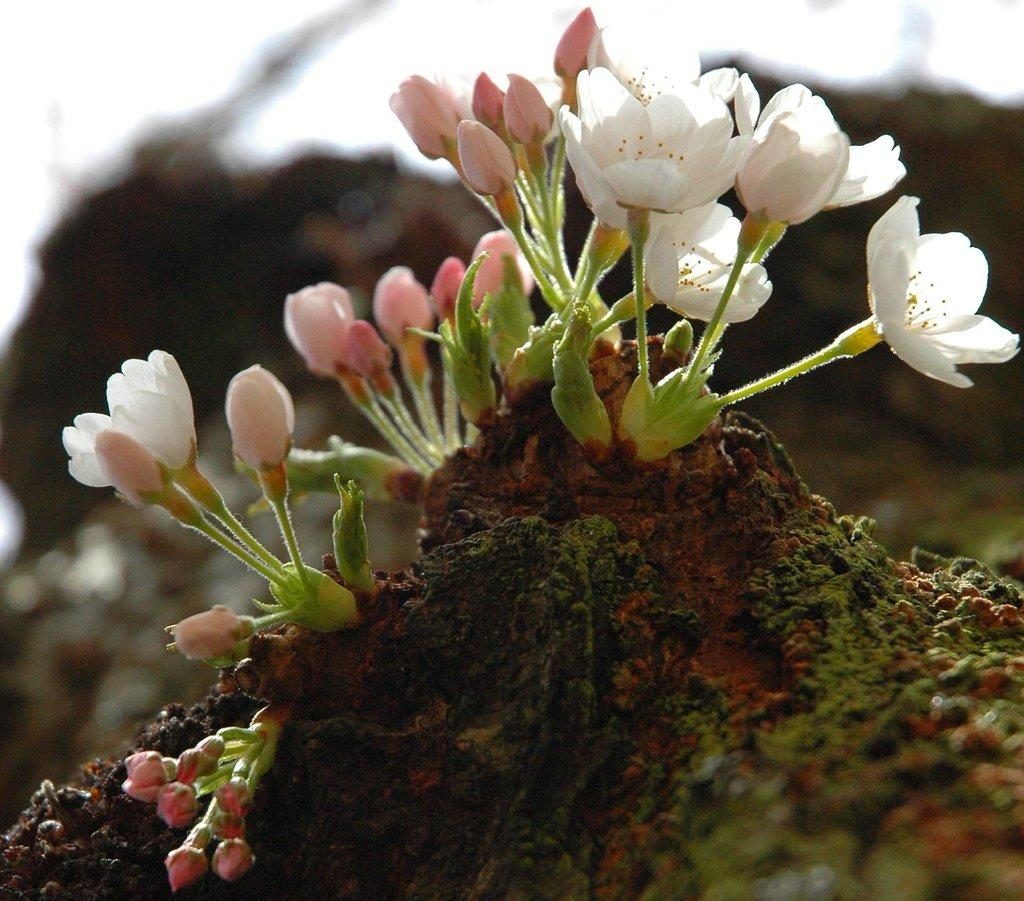What colors of flowers can be seen on the ground in the image? There are white and pink color flowers on the ground. Where are the pink color flower buds located in the image? The pink color flower buds are on the left side of the image. Can you describe the background of the image? The background of the image is blurred. How many passengers are visible in the image? There are no passengers present in the image; it features flowers on the ground. What type of net is used to catch the fifth flower in the image? There is no net or fifth flower present in the image. 